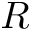<formula> <loc_0><loc_0><loc_500><loc_500>R</formula> 